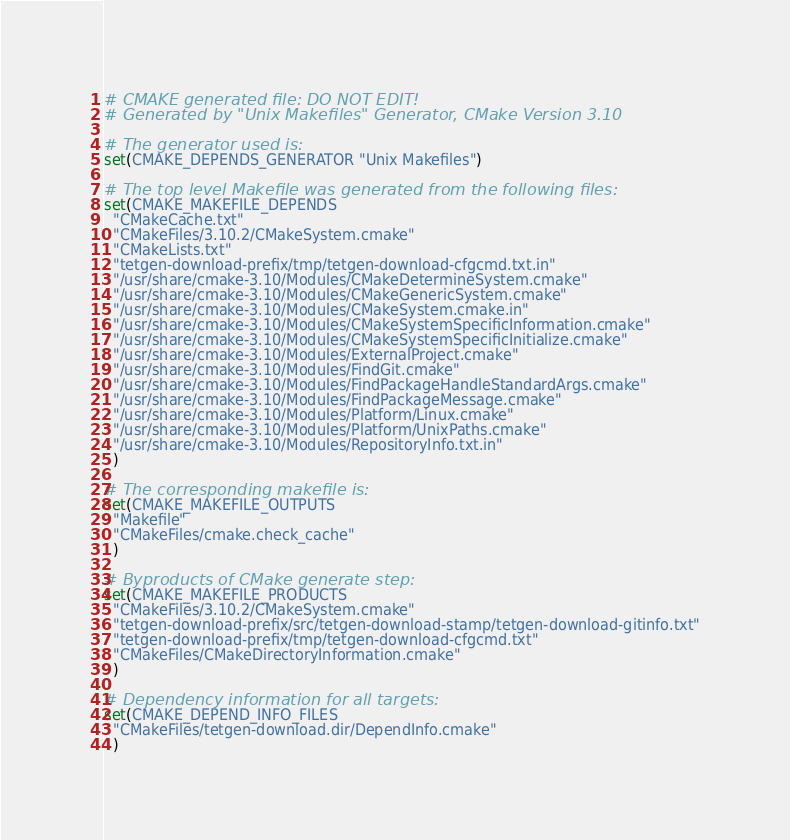Convert code to text. <code><loc_0><loc_0><loc_500><loc_500><_CMake_># CMAKE generated file: DO NOT EDIT!
# Generated by "Unix Makefiles" Generator, CMake Version 3.10

# The generator used is:
set(CMAKE_DEPENDS_GENERATOR "Unix Makefiles")

# The top level Makefile was generated from the following files:
set(CMAKE_MAKEFILE_DEPENDS
  "CMakeCache.txt"
  "CMakeFiles/3.10.2/CMakeSystem.cmake"
  "CMakeLists.txt"
  "tetgen-download-prefix/tmp/tetgen-download-cfgcmd.txt.in"
  "/usr/share/cmake-3.10/Modules/CMakeDetermineSystem.cmake"
  "/usr/share/cmake-3.10/Modules/CMakeGenericSystem.cmake"
  "/usr/share/cmake-3.10/Modules/CMakeSystem.cmake.in"
  "/usr/share/cmake-3.10/Modules/CMakeSystemSpecificInformation.cmake"
  "/usr/share/cmake-3.10/Modules/CMakeSystemSpecificInitialize.cmake"
  "/usr/share/cmake-3.10/Modules/ExternalProject.cmake"
  "/usr/share/cmake-3.10/Modules/FindGit.cmake"
  "/usr/share/cmake-3.10/Modules/FindPackageHandleStandardArgs.cmake"
  "/usr/share/cmake-3.10/Modules/FindPackageMessage.cmake"
  "/usr/share/cmake-3.10/Modules/Platform/Linux.cmake"
  "/usr/share/cmake-3.10/Modules/Platform/UnixPaths.cmake"
  "/usr/share/cmake-3.10/Modules/RepositoryInfo.txt.in"
  )

# The corresponding makefile is:
set(CMAKE_MAKEFILE_OUTPUTS
  "Makefile"
  "CMakeFiles/cmake.check_cache"
  )

# Byproducts of CMake generate step:
set(CMAKE_MAKEFILE_PRODUCTS
  "CMakeFiles/3.10.2/CMakeSystem.cmake"
  "tetgen-download-prefix/src/tetgen-download-stamp/tetgen-download-gitinfo.txt"
  "tetgen-download-prefix/tmp/tetgen-download-cfgcmd.txt"
  "CMakeFiles/CMakeDirectoryInformation.cmake"
  )

# Dependency information for all targets:
set(CMAKE_DEPEND_INFO_FILES
  "CMakeFiles/tetgen-download.dir/DependInfo.cmake"
  )
</code> 